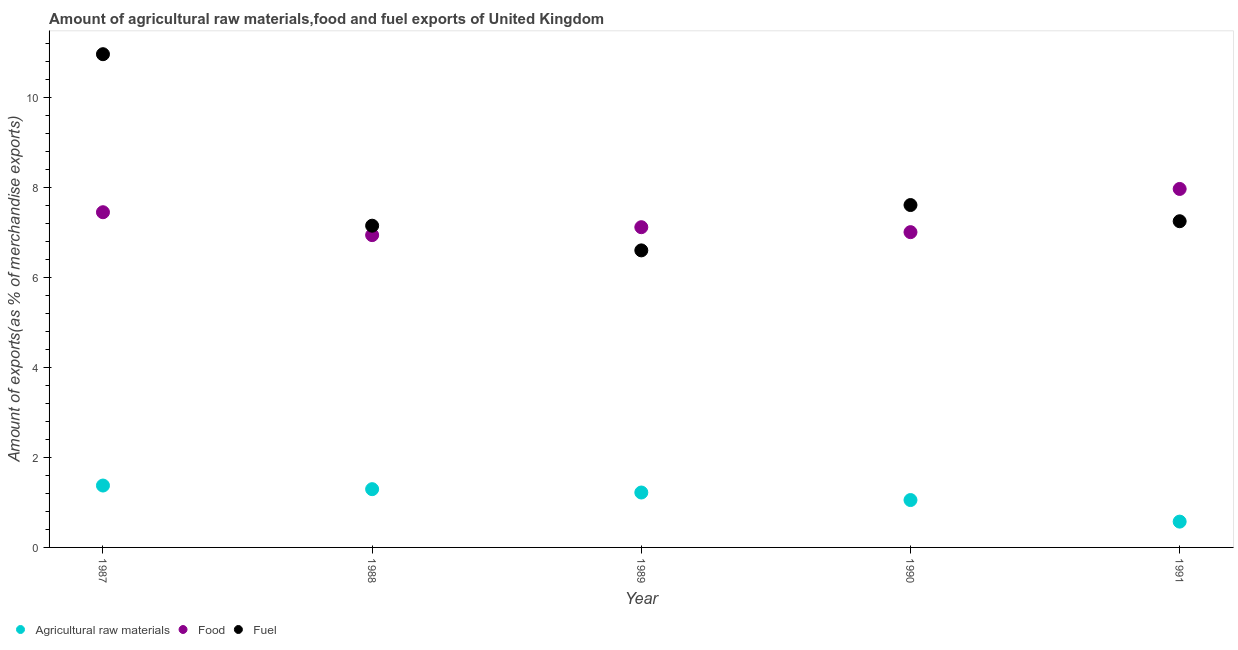How many different coloured dotlines are there?
Your answer should be compact. 3. What is the percentage of food exports in 1988?
Offer a very short reply. 6.94. Across all years, what is the maximum percentage of raw materials exports?
Provide a succinct answer. 1.37. Across all years, what is the minimum percentage of fuel exports?
Your answer should be compact. 6.6. In which year was the percentage of food exports minimum?
Offer a very short reply. 1988. What is the total percentage of raw materials exports in the graph?
Ensure brevity in your answer.  5.51. What is the difference between the percentage of fuel exports in 1989 and that in 1990?
Your answer should be very brief. -1.01. What is the difference between the percentage of raw materials exports in 1989 and the percentage of food exports in 1988?
Ensure brevity in your answer.  -5.72. What is the average percentage of raw materials exports per year?
Ensure brevity in your answer.  1.1. In the year 1987, what is the difference between the percentage of fuel exports and percentage of raw materials exports?
Keep it short and to the point. 9.58. In how many years, is the percentage of food exports greater than 1.2000000000000002 %?
Offer a very short reply. 5. What is the ratio of the percentage of food exports in 1987 to that in 1989?
Your answer should be compact. 1.05. What is the difference between the highest and the second highest percentage of raw materials exports?
Your answer should be very brief. 0.08. What is the difference between the highest and the lowest percentage of raw materials exports?
Ensure brevity in your answer.  0.8. Is it the case that in every year, the sum of the percentage of raw materials exports and percentage of food exports is greater than the percentage of fuel exports?
Your response must be concise. No. Does the percentage of food exports monotonically increase over the years?
Provide a short and direct response. No. Is the percentage of raw materials exports strictly less than the percentage of food exports over the years?
Provide a succinct answer. Yes. How many dotlines are there?
Your answer should be compact. 3. Are the values on the major ticks of Y-axis written in scientific E-notation?
Your response must be concise. No. Does the graph contain any zero values?
Your answer should be very brief. No. Where does the legend appear in the graph?
Offer a very short reply. Bottom left. How many legend labels are there?
Offer a terse response. 3. What is the title of the graph?
Keep it short and to the point. Amount of agricultural raw materials,food and fuel exports of United Kingdom. Does "Ages 65 and above" appear as one of the legend labels in the graph?
Provide a succinct answer. No. What is the label or title of the Y-axis?
Offer a very short reply. Amount of exports(as % of merchandise exports). What is the Amount of exports(as % of merchandise exports) of Agricultural raw materials in 1987?
Offer a very short reply. 1.37. What is the Amount of exports(as % of merchandise exports) in Food in 1987?
Offer a terse response. 7.45. What is the Amount of exports(as % of merchandise exports) in Fuel in 1987?
Your response must be concise. 10.96. What is the Amount of exports(as % of merchandise exports) of Agricultural raw materials in 1988?
Keep it short and to the point. 1.29. What is the Amount of exports(as % of merchandise exports) in Food in 1988?
Make the answer very short. 6.94. What is the Amount of exports(as % of merchandise exports) in Fuel in 1988?
Offer a very short reply. 7.15. What is the Amount of exports(as % of merchandise exports) in Agricultural raw materials in 1989?
Ensure brevity in your answer.  1.22. What is the Amount of exports(as % of merchandise exports) of Food in 1989?
Your answer should be very brief. 7.11. What is the Amount of exports(as % of merchandise exports) in Fuel in 1989?
Ensure brevity in your answer.  6.6. What is the Amount of exports(as % of merchandise exports) of Agricultural raw materials in 1990?
Your answer should be compact. 1.05. What is the Amount of exports(as % of merchandise exports) in Food in 1990?
Your response must be concise. 7. What is the Amount of exports(as % of merchandise exports) in Fuel in 1990?
Keep it short and to the point. 7.6. What is the Amount of exports(as % of merchandise exports) of Agricultural raw materials in 1991?
Your response must be concise. 0.57. What is the Amount of exports(as % of merchandise exports) of Food in 1991?
Make the answer very short. 7.96. What is the Amount of exports(as % of merchandise exports) in Fuel in 1991?
Keep it short and to the point. 7.25. Across all years, what is the maximum Amount of exports(as % of merchandise exports) of Agricultural raw materials?
Your answer should be very brief. 1.37. Across all years, what is the maximum Amount of exports(as % of merchandise exports) of Food?
Your answer should be very brief. 7.96. Across all years, what is the maximum Amount of exports(as % of merchandise exports) of Fuel?
Your answer should be compact. 10.96. Across all years, what is the minimum Amount of exports(as % of merchandise exports) in Agricultural raw materials?
Your answer should be compact. 0.57. Across all years, what is the minimum Amount of exports(as % of merchandise exports) of Food?
Provide a short and direct response. 6.94. Across all years, what is the minimum Amount of exports(as % of merchandise exports) of Fuel?
Your answer should be compact. 6.6. What is the total Amount of exports(as % of merchandise exports) of Agricultural raw materials in the graph?
Your response must be concise. 5.51. What is the total Amount of exports(as % of merchandise exports) of Food in the graph?
Your answer should be very brief. 36.46. What is the total Amount of exports(as % of merchandise exports) of Fuel in the graph?
Offer a very short reply. 39.55. What is the difference between the Amount of exports(as % of merchandise exports) of Agricultural raw materials in 1987 and that in 1988?
Offer a terse response. 0.08. What is the difference between the Amount of exports(as % of merchandise exports) in Food in 1987 and that in 1988?
Ensure brevity in your answer.  0.51. What is the difference between the Amount of exports(as % of merchandise exports) of Fuel in 1987 and that in 1988?
Give a very brief answer. 3.81. What is the difference between the Amount of exports(as % of merchandise exports) of Agricultural raw materials in 1987 and that in 1989?
Your answer should be compact. 0.15. What is the difference between the Amount of exports(as % of merchandise exports) of Food in 1987 and that in 1989?
Give a very brief answer. 0.33. What is the difference between the Amount of exports(as % of merchandise exports) in Fuel in 1987 and that in 1989?
Make the answer very short. 4.36. What is the difference between the Amount of exports(as % of merchandise exports) of Agricultural raw materials in 1987 and that in 1990?
Keep it short and to the point. 0.32. What is the difference between the Amount of exports(as % of merchandise exports) in Food in 1987 and that in 1990?
Ensure brevity in your answer.  0.44. What is the difference between the Amount of exports(as % of merchandise exports) in Fuel in 1987 and that in 1990?
Make the answer very short. 3.35. What is the difference between the Amount of exports(as % of merchandise exports) in Agricultural raw materials in 1987 and that in 1991?
Offer a very short reply. 0.8. What is the difference between the Amount of exports(as % of merchandise exports) of Food in 1987 and that in 1991?
Your answer should be very brief. -0.52. What is the difference between the Amount of exports(as % of merchandise exports) of Fuel in 1987 and that in 1991?
Offer a terse response. 3.71. What is the difference between the Amount of exports(as % of merchandise exports) in Agricultural raw materials in 1988 and that in 1989?
Your response must be concise. 0.07. What is the difference between the Amount of exports(as % of merchandise exports) of Food in 1988 and that in 1989?
Your response must be concise. -0.18. What is the difference between the Amount of exports(as % of merchandise exports) in Fuel in 1988 and that in 1989?
Your response must be concise. 0.55. What is the difference between the Amount of exports(as % of merchandise exports) in Agricultural raw materials in 1988 and that in 1990?
Your answer should be very brief. 0.24. What is the difference between the Amount of exports(as % of merchandise exports) in Food in 1988 and that in 1990?
Make the answer very short. -0.07. What is the difference between the Amount of exports(as % of merchandise exports) of Fuel in 1988 and that in 1990?
Ensure brevity in your answer.  -0.46. What is the difference between the Amount of exports(as % of merchandise exports) of Agricultural raw materials in 1988 and that in 1991?
Give a very brief answer. 0.72. What is the difference between the Amount of exports(as % of merchandise exports) in Food in 1988 and that in 1991?
Offer a very short reply. -1.03. What is the difference between the Amount of exports(as % of merchandise exports) of Fuel in 1988 and that in 1991?
Your answer should be compact. -0.1. What is the difference between the Amount of exports(as % of merchandise exports) in Agricultural raw materials in 1989 and that in 1990?
Ensure brevity in your answer.  0.17. What is the difference between the Amount of exports(as % of merchandise exports) of Food in 1989 and that in 1990?
Offer a terse response. 0.11. What is the difference between the Amount of exports(as % of merchandise exports) in Fuel in 1989 and that in 1990?
Ensure brevity in your answer.  -1.01. What is the difference between the Amount of exports(as % of merchandise exports) in Agricultural raw materials in 1989 and that in 1991?
Provide a succinct answer. 0.65. What is the difference between the Amount of exports(as % of merchandise exports) in Food in 1989 and that in 1991?
Your response must be concise. -0.85. What is the difference between the Amount of exports(as % of merchandise exports) in Fuel in 1989 and that in 1991?
Your answer should be very brief. -0.65. What is the difference between the Amount of exports(as % of merchandise exports) in Agricultural raw materials in 1990 and that in 1991?
Make the answer very short. 0.48. What is the difference between the Amount of exports(as % of merchandise exports) in Food in 1990 and that in 1991?
Ensure brevity in your answer.  -0.96. What is the difference between the Amount of exports(as % of merchandise exports) in Fuel in 1990 and that in 1991?
Give a very brief answer. 0.36. What is the difference between the Amount of exports(as % of merchandise exports) in Agricultural raw materials in 1987 and the Amount of exports(as % of merchandise exports) in Food in 1988?
Your answer should be very brief. -5.56. What is the difference between the Amount of exports(as % of merchandise exports) of Agricultural raw materials in 1987 and the Amount of exports(as % of merchandise exports) of Fuel in 1988?
Make the answer very short. -5.77. What is the difference between the Amount of exports(as % of merchandise exports) of Food in 1987 and the Amount of exports(as % of merchandise exports) of Fuel in 1988?
Your answer should be compact. 0.3. What is the difference between the Amount of exports(as % of merchandise exports) of Agricultural raw materials in 1987 and the Amount of exports(as % of merchandise exports) of Food in 1989?
Provide a succinct answer. -5.74. What is the difference between the Amount of exports(as % of merchandise exports) in Agricultural raw materials in 1987 and the Amount of exports(as % of merchandise exports) in Fuel in 1989?
Offer a terse response. -5.22. What is the difference between the Amount of exports(as % of merchandise exports) of Food in 1987 and the Amount of exports(as % of merchandise exports) of Fuel in 1989?
Keep it short and to the point. 0.85. What is the difference between the Amount of exports(as % of merchandise exports) of Agricultural raw materials in 1987 and the Amount of exports(as % of merchandise exports) of Food in 1990?
Make the answer very short. -5.63. What is the difference between the Amount of exports(as % of merchandise exports) in Agricultural raw materials in 1987 and the Amount of exports(as % of merchandise exports) in Fuel in 1990?
Make the answer very short. -6.23. What is the difference between the Amount of exports(as % of merchandise exports) in Food in 1987 and the Amount of exports(as % of merchandise exports) in Fuel in 1990?
Provide a short and direct response. -0.16. What is the difference between the Amount of exports(as % of merchandise exports) of Agricultural raw materials in 1987 and the Amount of exports(as % of merchandise exports) of Food in 1991?
Provide a succinct answer. -6.59. What is the difference between the Amount of exports(as % of merchandise exports) of Agricultural raw materials in 1987 and the Amount of exports(as % of merchandise exports) of Fuel in 1991?
Keep it short and to the point. -5.87. What is the difference between the Amount of exports(as % of merchandise exports) in Food in 1987 and the Amount of exports(as % of merchandise exports) in Fuel in 1991?
Your answer should be very brief. 0.2. What is the difference between the Amount of exports(as % of merchandise exports) of Agricultural raw materials in 1988 and the Amount of exports(as % of merchandise exports) of Food in 1989?
Ensure brevity in your answer.  -5.82. What is the difference between the Amount of exports(as % of merchandise exports) of Agricultural raw materials in 1988 and the Amount of exports(as % of merchandise exports) of Fuel in 1989?
Give a very brief answer. -5.3. What is the difference between the Amount of exports(as % of merchandise exports) of Food in 1988 and the Amount of exports(as % of merchandise exports) of Fuel in 1989?
Offer a very short reply. 0.34. What is the difference between the Amount of exports(as % of merchandise exports) of Agricultural raw materials in 1988 and the Amount of exports(as % of merchandise exports) of Food in 1990?
Keep it short and to the point. -5.71. What is the difference between the Amount of exports(as % of merchandise exports) in Agricultural raw materials in 1988 and the Amount of exports(as % of merchandise exports) in Fuel in 1990?
Keep it short and to the point. -6.31. What is the difference between the Amount of exports(as % of merchandise exports) of Food in 1988 and the Amount of exports(as % of merchandise exports) of Fuel in 1990?
Offer a very short reply. -0.67. What is the difference between the Amount of exports(as % of merchandise exports) in Agricultural raw materials in 1988 and the Amount of exports(as % of merchandise exports) in Food in 1991?
Give a very brief answer. -6.67. What is the difference between the Amount of exports(as % of merchandise exports) in Agricultural raw materials in 1988 and the Amount of exports(as % of merchandise exports) in Fuel in 1991?
Your answer should be very brief. -5.95. What is the difference between the Amount of exports(as % of merchandise exports) of Food in 1988 and the Amount of exports(as % of merchandise exports) of Fuel in 1991?
Your answer should be compact. -0.31. What is the difference between the Amount of exports(as % of merchandise exports) of Agricultural raw materials in 1989 and the Amount of exports(as % of merchandise exports) of Food in 1990?
Your answer should be compact. -5.78. What is the difference between the Amount of exports(as % of merchandise exports) in Agricultural raw materials in 1989 and the Amount of exports(as % of merchandise exports) in Fuel in 1990?
Provide a short and direct response. -6.39. What is the difference between the Amount of exports(as % of merchandise exports) in Food in 1989 and the Amount of exports(as % of merchandise exports) in Fuel in 1990?
Give a very brief answer. -0.49. What is the difference between the Amount of exports(as % of merchandise exports) in Agricultural raw materials in 1989 and the Amount of exports(as % of merchandise exports) in Food in 1991?
Provide a succinct answer. -6.74. What is the difference between the Amount of exports(as % of merchandise exports) in Agricultural raw materials in 1989 and the Amount of exports(as % of merchandise exports) in Fuel in 1991?
Ensure brevity in your answer.  -6.03. What is the difference between the Amount of exports(as % of merchandise exports) of Food in 1989 and the Amount of exports(as % of merchandise exports) of Fuel in 1991?
Provide a succinct answer. -0.13. What is the difference between the Amount of exports(as % of merchandise exports) in Agricultural raw materials in 1990 and the Amount of exports(as % of merchandise exports) in Food in 1991?
Offer a terse response. -6.91. What is the difference between the Amount of exports(as % of merchandise exports) of Agricultural raw materials in 1990 and the Amount of exports(as % of merchandise exports) of Fuel in 1991?
Offer a terse response. -6.19. What is the difference between the Amount of exports(as % of merchandise exports) of Food in 1990 and the Amount of exports(as % of merchandise exports) of Fuel in 1991?
Provide a succinct answer. -0.24. What is the average Amount of exports(as % of merchandise exports) in Agricultural raw materials per year?
Offer a very short reply. 1.1. What is the average Amount of exports(as % of merchandise exports) in Food per year?
Give a very brief answer. 7.29. What is the average Amount of exports(as % of merchandise exports) in Fuel per year?
Give a very brief answer. 7.91. In the year 1987, what is the difference between the Amount of exports(as % of merchandise exports) of Agricultural raw materials and Amount of exports(as % of merchandise exports) of Food?
Keep it short and to the point. -6.07. In the year 1987, what is the difference between the Amount of exports(as % of merchandise exports) of Agricultural raw materials and Amount of exports(as % of merchandise exports) of Fuel?
Your answer should be very brief. -9.58. In the year 1987, what is the difference between the Amount of exports(as % of merchandise exports) in Food and Amount of exports(as % of merchandise exports) in Fuel?
Keep it short and to the point. -3.51. In the year 1988, what is the difference between the Amount of exports(as % of merchandise exports) in Agricultural raw materials and Amount of exports(as % of merchandise exports) in Food?
Provide a succinct answer. -5.64. In the year 1988, what is the difference between the Amount of exports(as % of merchandise exports) of Agricultural raw materials and Amount of exports(as % of merchandise exports) of Fuel?
Your answer should be very brief. -5.85. In the year 1988, what is the difference between the Amount of exports(as % of merchandise exports) in Food and Amount of exports(as % of merchandise exports) in Fuel?
Your response must be concise. -0.21. In the year 1989, what is the difference between the Amount of exports(as % of merchandise exports) in Agricultural raw materials and Amount of exports(as % of merchandise exports) in Food?
Keep it short and to the point. -5.89. In the year 1989, what is the difference between the Amount of exports(as % of merchandise exports) of Agricultural raw materials and Amount of exports(as % of merchandise exports) of Fuel?
Provide a short and direct response. -5.38. In the year 1989, what is the difference between the Amount of exports(as % of merchandise exports) of Food and Amount of exports(as % of merchandise exports) of Fuel?
Your answer should be compact. 0.52. In the year 1990, what is the difference between the Amount of exports(as % of merchandise exports) in Agricultural raw materials and Amount of exports(as % of merchandise exports) in Food?
Give a very brief answer. -5.95. In the year 1990, what is the difference between the Amount of exports(as % of merchandise exports) of Agricultural raw materials and Amount of exports(as % of merchandise exports) of Fuel?
Give a very brief answer. -6.55. In the year 1990, what is the difference between the Amount of exports(as % of merchandise exports) in Food and Amount of exports(as % of merchandise exports) in Fuel?
Your answer should be very brief. -0.6. In the year 1991, what is the difference between the Amount of exports(as % of merchandise exports) in Agricultural raw materials and Amount of exports(as % of merchandise exports) in Food?
Give a very brief answer. -7.39. In the year 1991, what is the difference between the Amount of exports(as % of merchandise exports) in Agricultural raw materials and Amount of exports(as % of merchandise exports) in Fuel?
Make the answer very short. -6.67. In the year 1991, what is the difference between the Amount of exports(as % of merchandise exports) of Food and Amount of exports(as % of merchandise exports) of Fuel?
Offer a very short reply. 0.72. What is the ratio of the Amount of exports(as % of merchandise exports) of Agricultural raw materials in 1987 to that in 1988?
Give a very brief answer. 1.06. What is the ratio of the Amount of exports(as % of merchandise exports) in Food in 1987 to that in 1988?
Your answer should be compact. 1.07. What is the ratio of the Amount of exports(as % of merchandise exports) of Fuel in 1987 to that in 1988?
Offer a very short reply. 1.53. What is the ratio of the Amount of exports(as % of merchandise exports) in Agricultural raw materials in 1987 to that in 1989?
Your answer should be very brief. 1.13. What is the ratio of the Amount of exports(as % of merchandise exports) of Food in 1987 to that in 1989?
Your response must be concise. 1.05. What is the ratio of the Amount of exports(as % of merchandise exports) in Fuel in 1987 to that in 1989?
Your answer should be compact. 1.66. What is the ratio of the Amount of exports(as % of merchandise exports) of Agricultural raw materials in 1987 to that in 1990?
Your answer should be compact. 1.31. What is the ratio of the Amount of exports(as % of merchandise exports) of Food in 1987 to that in 1990?
Give a very brief answer. 1.06. What is the ratio of the Amount of exports(as % of merchandise exports) of Fuel in 1987 to that in 1990?
Offer a very short reply. 1.44. What is the ratio of the Amount of exports(as % of merchandise exports) of Agricultural raw materials in 1987 to that in 1991?
Your answer should be very brief. 2.4. What is the ratio of the Amount of exports(as % of merchandise exports) of Food in 1987 to that in 1991?
Give a very brief answer. 0.94. What is the ratio of the Amount of exports(as % of merchandise exports) in Fuel in 1987 to that in 1991?
Provide a short and direct response. 1.51. What is the ratio of the Amount of exports(as % of merchandise exports) of Agricultural raw materials in 1988 to that in 1989?
Offer a very short reply. 1.06. What is the ratio of the Amount of exports(as % of merchandise exports) in Food in 1988 to that in 1989?
Offer a terse response. 0.98. What is the ratio of the Amount of exports(as % of merchandise exports) of Fuel in 1988 to that in 1989?
Provide a succinct answer. 1.08. What is the ratio of the Amount of exports(as % of merchandise exports) of Agricultural raw materials in 1988 to that in 1990?
Your response must be concise. 1.23. What is the ratio of the Amount of exports(as % of merchandise exports) in Food in 1988 to that in 1990?
Provide a succinct answer. 0.99. What is the ratio of the Amount of exports(as % of merchandise exports) in Fuel in 1988 to that in 1990?
Offer a terse response. 0.94. What is the ratio of the Amount of exports(as % of merchandise exports) in Agricultural raw materials in 1988 to that in 1991?
Ensure brevity in your answer.  2.26. What is the ratio of the Amount of exports(as % of merchandise exports) in Food in 1988 to that in 1991?
Your answer should be very brief. 0.87. What is the ratio of the Amount of exports(as % of merchandise exports) in Fuel in 1988 to that in 1991?
Offer a very short reply. 0.99. What is the ratio of the Amount of exports(as % of merchandise exports) in Agricultural raw materials in 1989 to that in 1990?
Provide a short and direct response. 1.16. What is the ratio of the Amount of exports(as % of merchandise exports) of Food in 1989 to that in 1990?
Give a very brief answer. 1.02. What is the ratio of the Amount of exports(as % of merchandise exports) in Fuel in 1989 to that in 1990?
Give a very brief answer. 0.87. What is the ratio of the Amount of exports(as % of merchandise exports) of Agricultural raw materials in 1989 to that in 1991?
Offer a very short reply. 2.13. What is the ratio of the Amount of exports(as % of merchandise exports) in Food in 1989 to that in 1991?
Provide a short and direct response. 0.89. What is the ratio of the Amount of exports(as % of merchandise exports) of Fuel in 1989 to that in 1991?
Ensure brevity in your answer.  0.91. What is the ratio of the Amount of exports(as % of merchandise exports) of Agricultural raw materials in 1990 to that in 1991?
Your response must be concise. 1.84. What is the ratio of the Amount of exports(as % of merchandise exports) of Food in 1990 to that in 1991?
Your response must be concise. 0.88. What is the ratio of the Amount of exports(as % of merchandise exports) of Fuel in 1990 to that in 1991?
Your answer should be compact. 1.05. What is the difference between the highest and the second highest Amount of exports(as % of merchandise exports) in Agricultural raw materials?
Give a very brief answer. 0.08. What is the difference between the highest and the second highest Amount of exports(as % of merchandise exports) of Food?
Your response must be concise. 0.52. What is the difference between the highest and the second highest Amount of exports(as % of merchandise exports) in Fuel?
Keep it short and to the point. 3.35. What is the difference between the highest and the lowest Amount of exports(as % of merchandise exports) in Agricultural raw materials?
Your response must be concise. 0.8. What is the difference between the highest and the lowest Amount of exports(as % of merchandise exports) in Food?
Make the answer very short. 1.03. What is the difference between the highest and the lowest Amount of exports(as % of merchandise exports) in Fuel?
Offer a terse response. 4.36. 